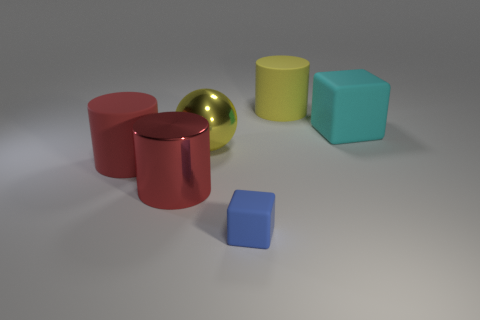Subtract all large red cylinders. How many cylinders are left? 1 Add 1 metallic cylinders. How many objects exist? 7 Subtract all balls. How many objects are left? 5 Subtract 0 yellow cubes. How many objects are left? 6 Subtract all metal things. Subtract all big gray matte cubes. How many objects are left? 4 Add 5 yellow spheres. How many yellow spheres are left? 6 Add 5 large yellow spheres. How many large yellow spheres exist? 6 